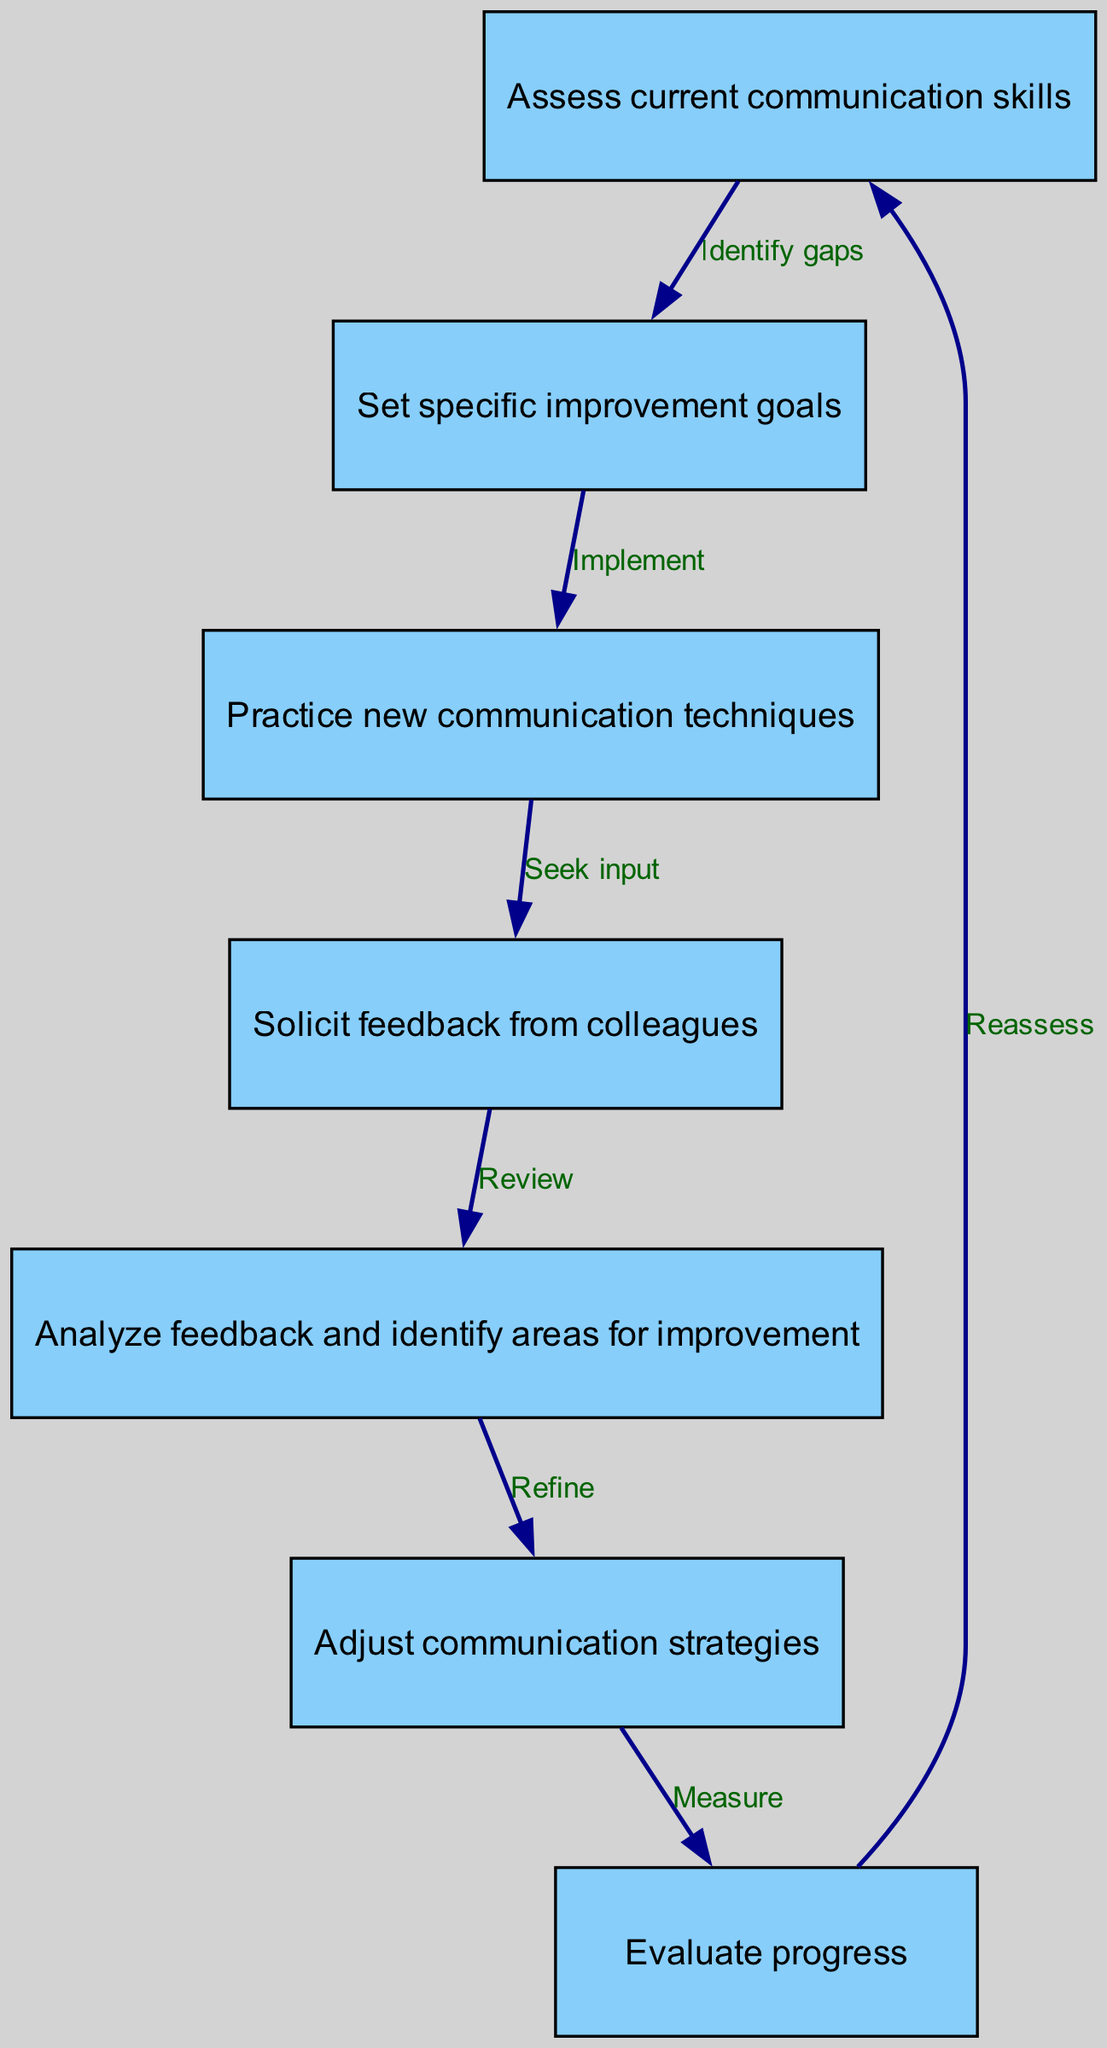What is the first step in the feedback loop? The first node in the diagram represents the first step, which is "Assess current communication skills."
Answer: Assess current communication skills How many nodes are in the diagram? By counting the individual nodes listed in the diagram, there are a total of seven nodes.
Answer: Seven What is the relationship between "Solicit feedback from colleagues" and "Analyze feedback and identify areas for improvement"? The edge connecting these two nodes indicates that after seeking feedback, the next logical step is to analyze that feedback.
Answer: Review Which step directly follows setting specific improvement goals? The diagram shows that the step immediately following "Set specific improvement goals" is "Practice new communication techniques."
Answer: Practice new communication techniques What is the final step before the loop reassesses current communication skills? The last step before returning to reassess is "Evaluate progress." This step measures the effectiveness of the communication strategies.
Answer: Evaluate progress How many edges are present in the diagram? Each edge represents a direct connection between nodes, and upon counting, there are a total of six edges in the diagram.
Answer: Six What are the two steps connected by the edge labeled "Refine"? The edge labeled "Refine" connects "Analyze feedback and identify areas for improvement" and "Adjust communication strategies," indicating a relationship of feedback leading to refinement.
Answer: Analyze feedback and identify areas for improvement, Adjust communication strategies Which node indicates a process where input is sought? The node "Solicit feedback from colleagues" clearly signifies the process where input is requested from others to enhance communication skills.
Answer: Solicit feedback from colleagues 